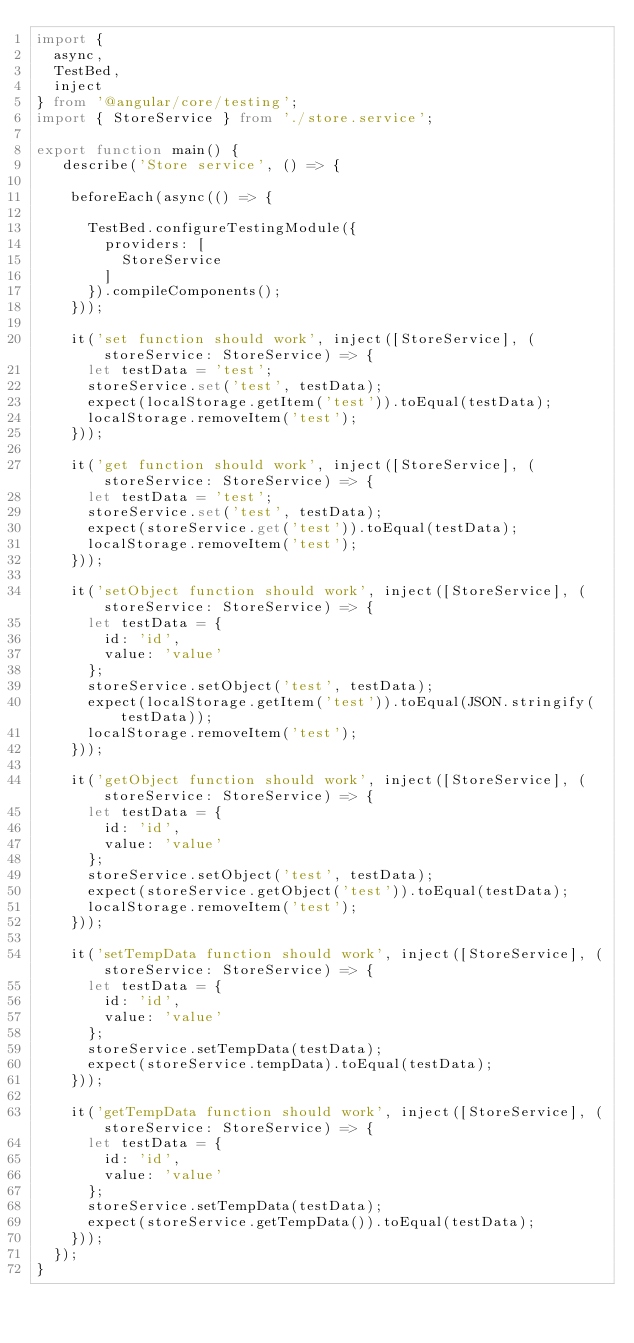Convert code to text. <code><loc_0><loc_0><loc_500><loc_500><_TypeScript_>import {
  async,
  TestBed,
  inject
} from '@angular/core/testing';
import { StoreService } from './store.service';

export function main() {
   describe('Store service', () => {

    beforeEach(async(() => {

      TestBed.configureTestingModule({
        providers: [
          StoreService
        ]
      }).compileComponents();
    }));

    it('set function should work', inject([StoreService], (storeService: StoreService) => {
      let testData = 'test';
      storeService.set('test', testData);
      expect(localStorage.getItem('test')).toEqual(testData);
      localStorage.removeItem('test');
    }));

    it('get function should work', inject([StoreService], (storeService: StoreService) => {
      let testData = 'test';
      storeService.set('test', testData);
      expect(storeService.get('test')).toEqual(testData);
      localStorage.removeItem('test');
    }));

    it('setObject function should work', inject([StoreService], (storeService: StoreService) => {
      let testData = {
        id: 'id',
        value: 'value'
      };
      storeService.setObject('test', testData);
      expect(localStorage.getItem('test')).toEqual(JSON.stringify(testData));
      localStorage.removeItem('test');
    }));

    it('getObject function should work', inject([StoreService], (storeService: StoreService) => {
      let testData = {
        id: 'id',
        value: 'value'
      };
      storeService.setObject('test', testData);
      expect(storeService.getObject('test')).toEqual(testData);
      localStorage.removeItem('test');
    }));

    it('setTempData function should work', inject([StoreService], (storeService: StoreService) => {
      let testData = {
        id: 'id',
        value: 'value'
      };
      storeService.setTempData(testData);
      expect(storeService.tempData).toEqual(testData);
    }));

    it('getTempData function should work', inject([StoreService], (storeService: StoreService) => {
      let testData = {
        id: 'id',
        value: 'value'
      };
      storeService.setTempData(testData);
      expect(storeService.getTempData()).toEqual(testData);
    }));
  });
}
</code> 